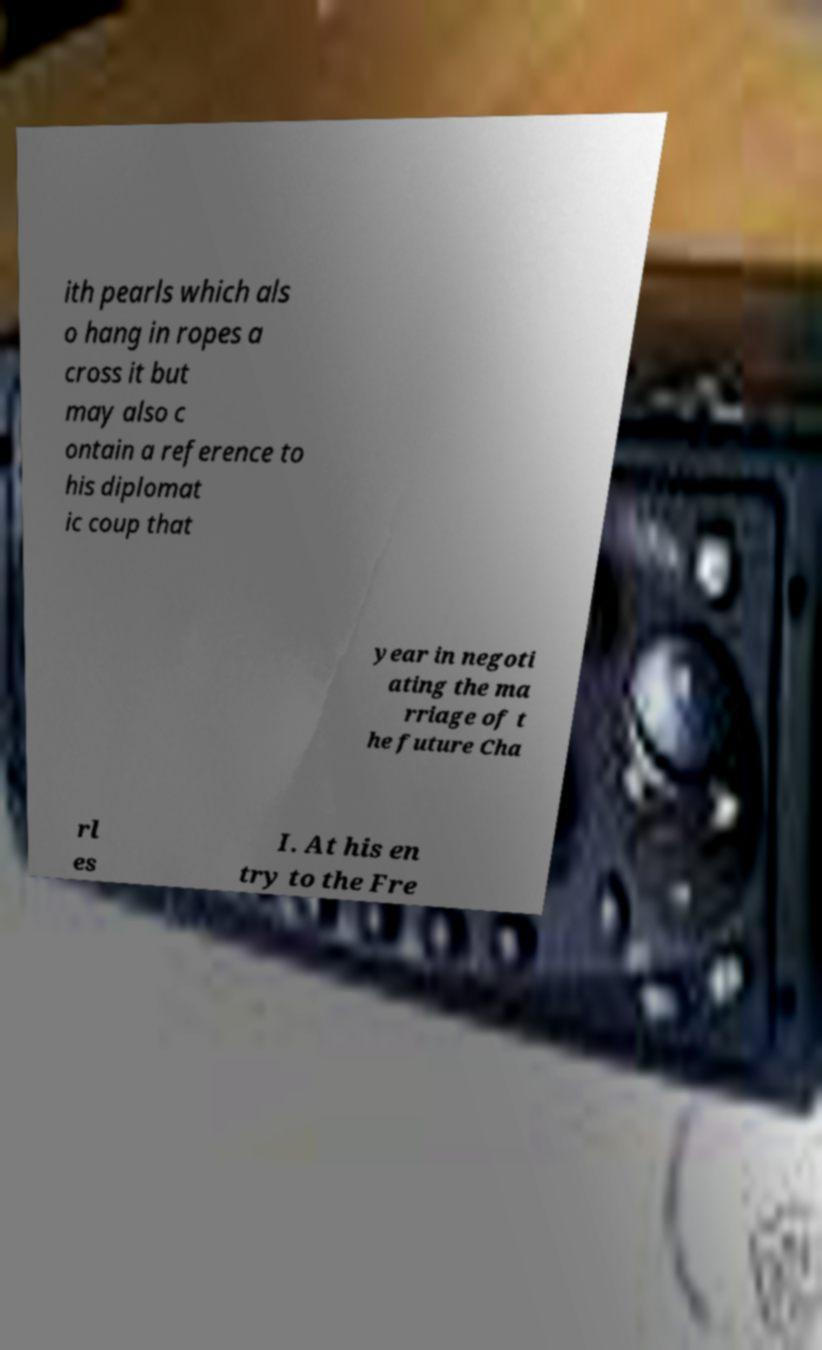I need the written content from this picture converted into text. Can you do that? ith pearls which als o hang in ropes a cross it but may also c ontain a reference to his diplomat ic coup that year in negoti ating the ma rriage of t he future Cha rl es I. At his en try to the Fre 